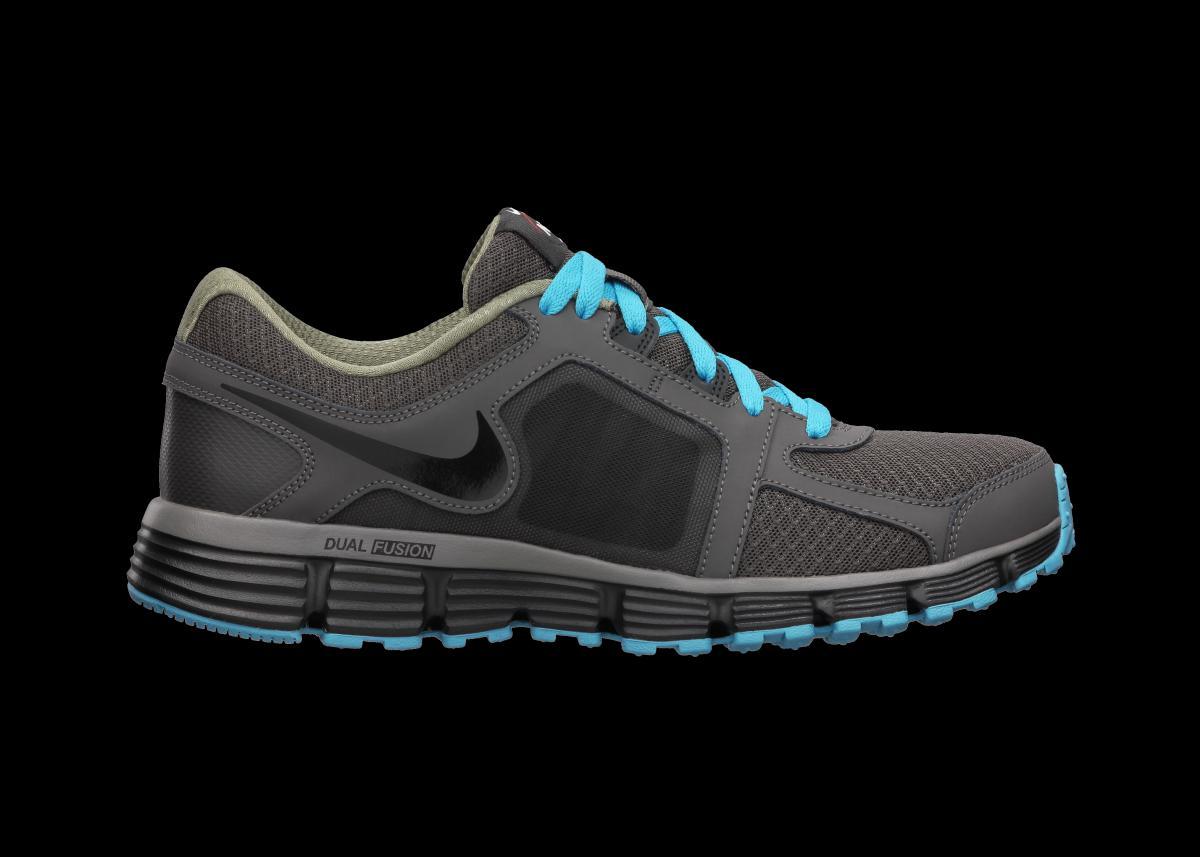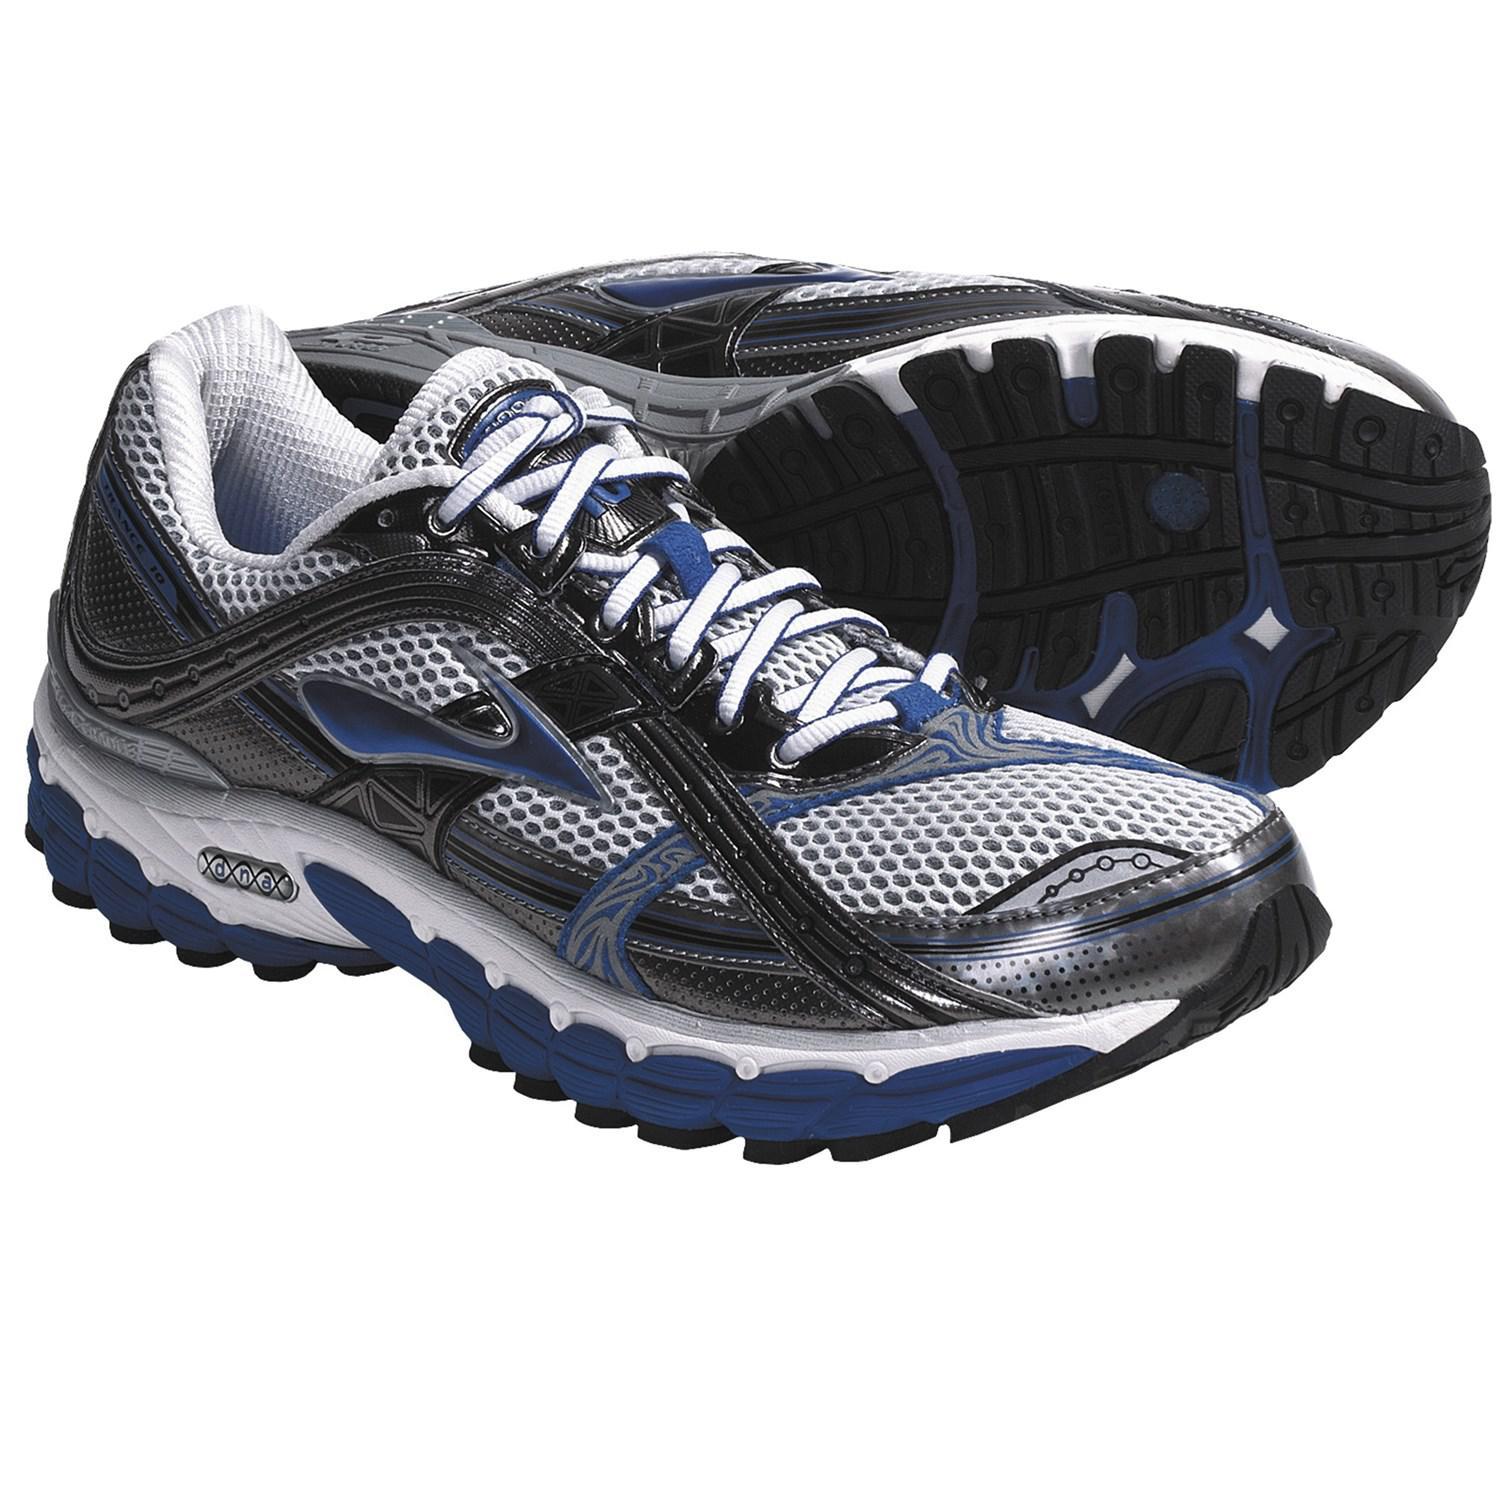The first image is the image on the left, the second image is the image on the right. Evaluate the accuracy of this statement regarding the images: "One image shows a pair of sneakers and the other image features a single right-facing sneaker, and all sneakers feature some shade of blue somewhere.". Is it true? Answer yes or no. Yes. The first image is the image on the left, the second image is the image on the right. Examine the images to the left and right. Is the description "The right image contains exactly one shoe." accurate? Answer yes or no. No. 